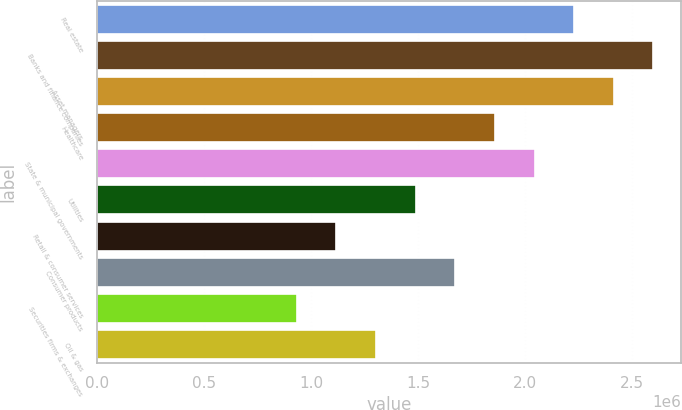Convert chart. <chart><loc_0><loc_0><loc_500><loc_500><bar_chart><fcel>Real estate<fcel>Banks and finance companies<fcel>Asset managers<fcel>Healthcare<fcel>State & municipal governments<fcel>Utilities<fcel>Retail & consumer services<fcel>Consumer products<fcel>Securities firms & exchanges<fcel>Oil & gas<nl><fcel>2.2291e+06<fcel>2.59911e+06<fcel>2.4141e+06<fcel>1.8591e+06<fcel>2.0441e+06<fcel>1.48909e+06<fcel>1.11909e+06<fcel>1.6741e+06<fcel>934086<fcel>1.30409e+06<nl></chart> 